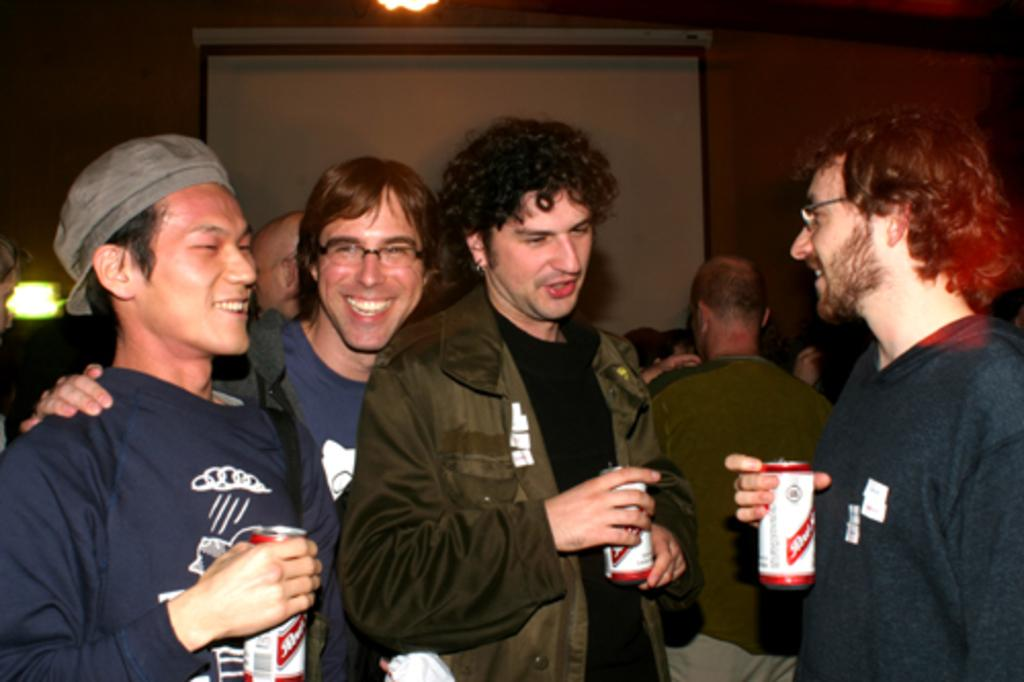How many people are present in the image? There are four people in the image. What are the people holding in the image? The people are holding tins. What are the people doing in the image? The people are standing. What type of apparel is the squirrel wearing in the image? There is no squirrel present in the image, so it cannot be determined what type of apparel it might be wearing. 